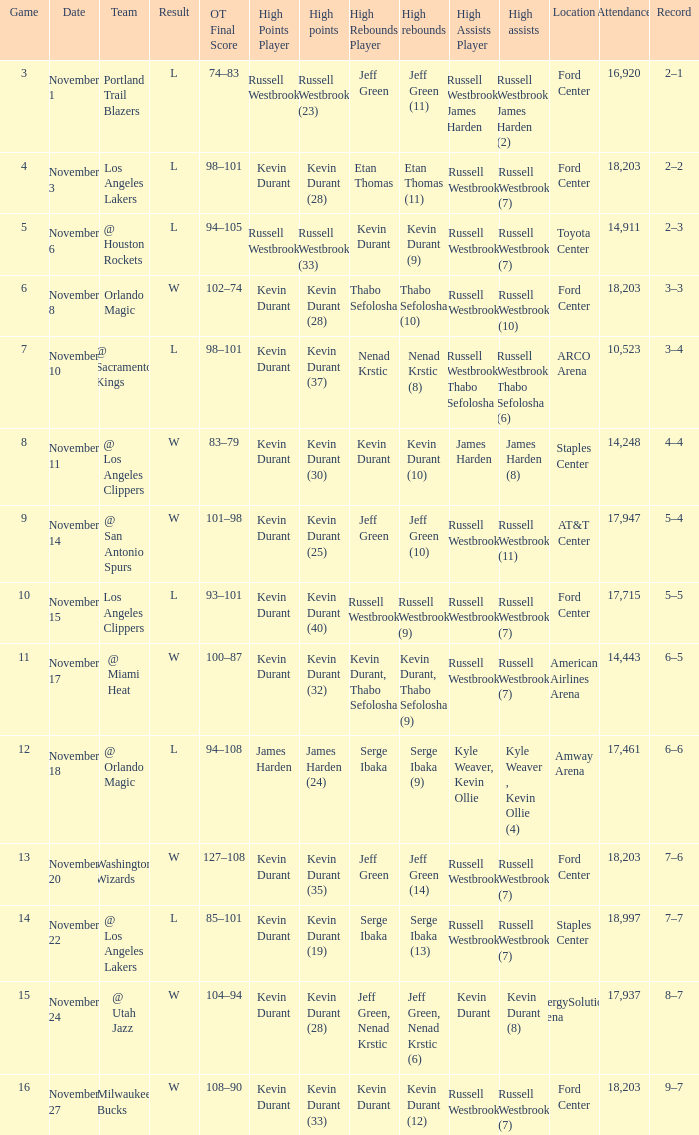Where was the game in which Kevin Durant (25) did the most high points played? AT&T Center 17,947. 